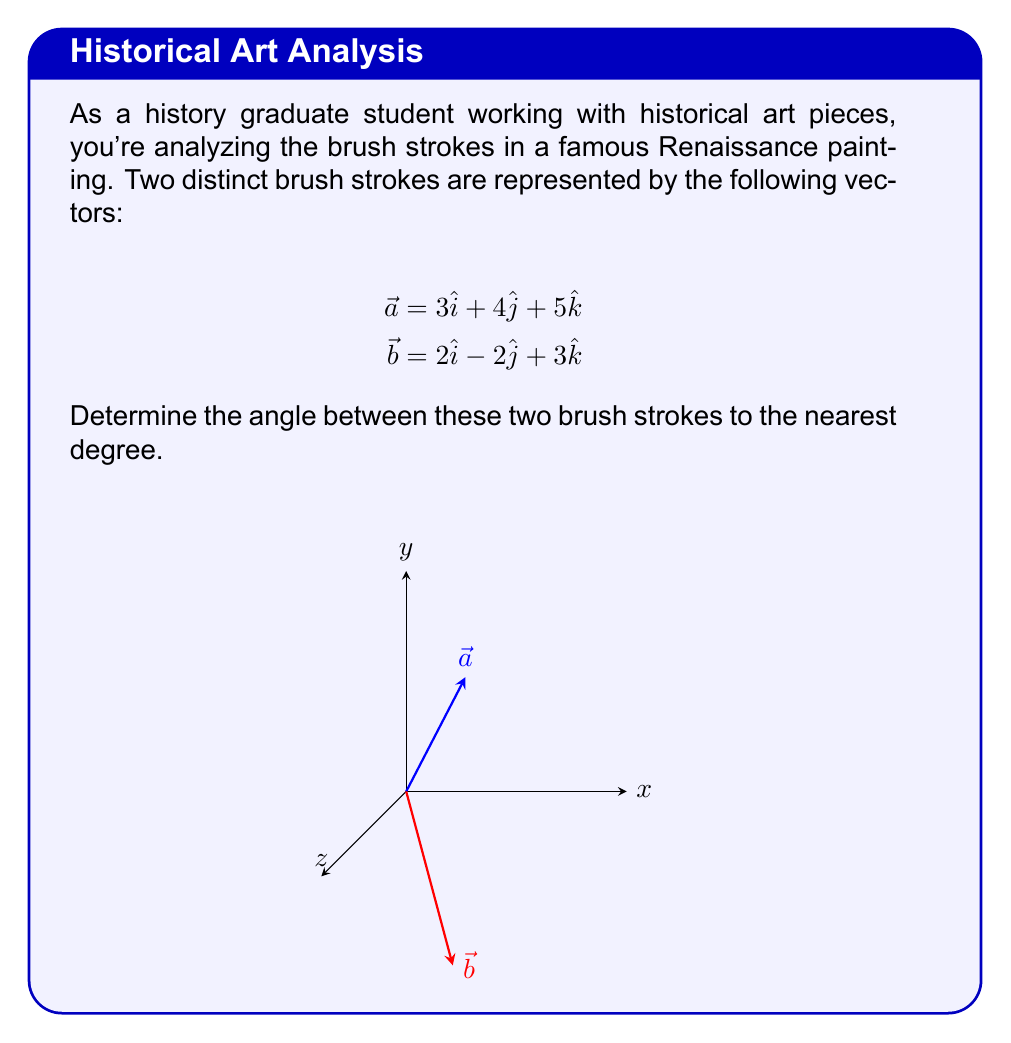Give your solution to this math problem. To find the angle between two vectors, we can use the dot product formula:

$$\cos \theta = \frac{\vec{a} \cdot \vec{b}}{|\vec{a}||\vec{b}|}$$

Step 1: Calculate the dot product $\vec{a} \cdot \vec{b}$
$$\vec{a} \cdot \vec{b} = (3)(2) + (4)(-2) + (5)(3) = 6 - 8 + 15 = 13$$

Step 2: Calculate the magnitudes of $\vec{a}$ and $\vec{b}$
$$|\vec{a}| = \sqrt{3^2 + 4^2 + 5^2} = \sqrt{50}$$
$$|\vec{b}| = \sqrt{2^2 + (-2)^2 + 3^2} = \sqrt{17}$$

Step 3: Substitute into the formula
$$\cos \theta = \frac{13}{\sqrt{50}\sqrt{17}}$$

Step 4: Calculate the angle using inverse cosine
$$\theta = \arccos\left(\frac{13}{\sqrt{50}\sqrt{17}}\right)$$

Step 5: Convert to degrees and round to the nearest degree
$$\theta \approx 44.42° \approx 44°$$
Answer: 44° 